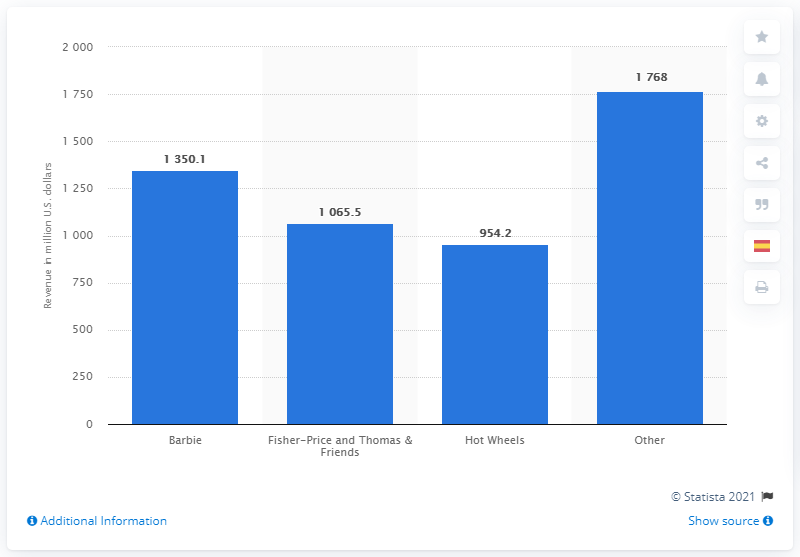Outline some significant characteristics in this image. Mattel's toy brand in 2020 was Barbie. In 2020, the global revenue generated from Mattel's Barbie brand was 1,350.1 million 